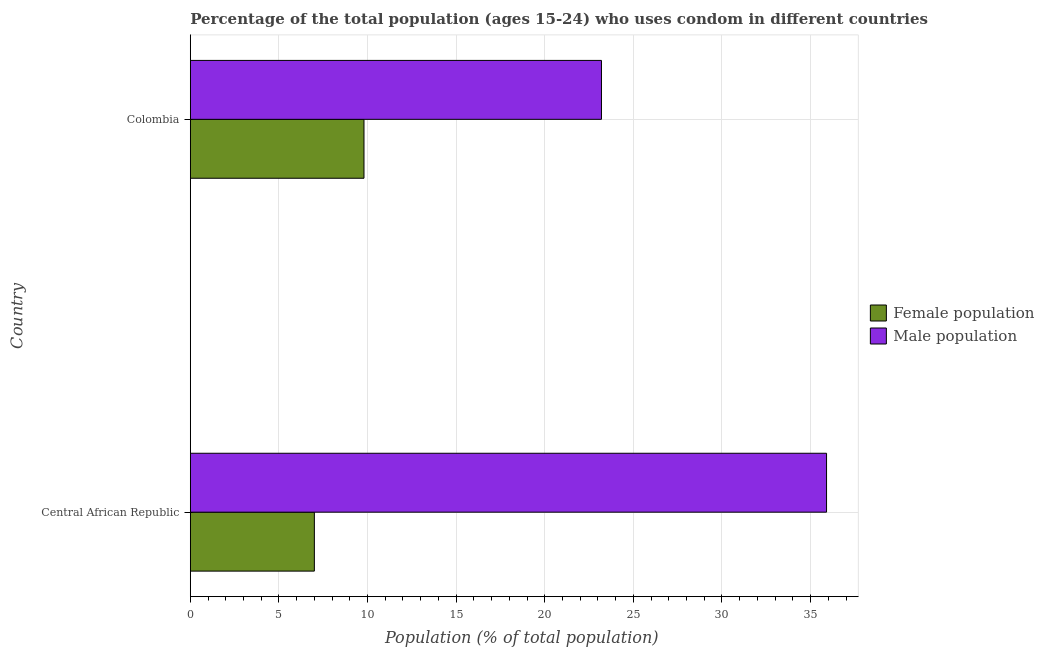How many groups of bars are there?
Offer a terse response. 2. Are the number of bars on each tick of the Y-axis equal?
Offer a very short reply. Yes. How many bars are there on the 1st tick from the top?
Provide a short and direct response. 2. How many bars are there on the 2nd tick from the bottom?
Make the answer very short. 2. What is the label of the 2nd group of bars from the top?
Keep it short and to the point. Central African Republic. In how many cases, is the number of bars for a given country not equal to the number of legend labels?
Your response must be concise. 0. What is the female population in Central African Republic?
Keep it short and to the point. 7. Across all countries, what is the maximum male population?
Your response must be concise. 35.9. Across all countries, what is the minimum male population?
Provide a short and direct response. 23.2. In which country was the female population minimum?
Offer a terse response. Central African Republic. What is the total male population in the graph?
Your response must be concise. 59.1. What is the difference between the female population in Central African Republic and that in Colombia?
Make the answer very short. -2.8. What is the difference between the male population in Central African Republic and the female population in Colombia?
Keep it short and to the point. 26.1. What is the difference between the male population and female population in Central African Republic?
Provide a succinct answer. 28.9. What is the ratio of the female population in Central African Republic to that in Colombia?
Your answer should be compact. 0.71. Is the difference between the male population in Central African Republic and Colombia greater than the difference between the female population in Central African Republic and Colombia?
Your answer should be compact. Yes. What does the 2nd bar from the top in Central African Republic represents?
Make the answer very short. Female population. What does the 1st bar from the bottom in Colombia represents?
Your answer should be compact. Female population. How many bars are there?
Your answer should be compact. 4. How many countries are there in the graph?
Ensure brevity in your answer.  2. What is the difference between two consecutive major ticks on the X-axis?
Your response must be concise. 5. Are the values on the major ticks of X-axis written in scientific E-notation?
Ensure brevity in your answer.  No. Does the graph contain any zero values?
Keep it short and to the point. No. What is the title of the graph?
Make the answer very short. Percentage of the total population (ages 15-24) who uses condom in different countries. Does "Under-five" appear as one of the legend labels in the graph?
Offer a terse response. No. What is the label or title of the X-axis?
Give a very brief answer. Population (% of total population) . What is the label or title of the Y-axis?
Provide a succinct answer. Country. What is the Population (% of total population)  of Male population in Central African Republic?
Provide a short and direct response. 35.9. What is the Population (% of total population)  of Female population in Colombia?
Offer a very short reply. 9.8. What is the Population (% of total population)  of Male population in Colombia?
Make the answer very short. 23.2. Across all countries, what is the maximum Population (% of total population)  of Male population?
Keep it short and to the point. 35.9. Across all countries, what is the minimum Population (% of total population)  of Male population?
Offer a terse response. 23.2. What is the total Population (% of total population)  of Male population in the graph?
Provide a succinct answer. 59.1. What is the difference between the Population (% of total population)  in Male population in Central African Republic and that in Colombia?
Your answer should be very brief. 12.7. What is the difference between the Population (% of total population)  of Female population in Central African Republic and the Population (% of total population)  of Male population in Colombia?
Ensure brevity in your answer.  -16.2. What is the average Population (% of total population)  of Male population per country?
Provide a succinct answer. 29.55. What is the difference between the Population (% of total population)  in Female population and Population (% of total population)  in Male population in Central African Republic?
Provide a short and direct response. -28.9. What is the difference between the Population (% of total population)  in Female population and Population (% of total population)  in Male population in Colombia?
Ensure brevity in your answer.  -13.4. What is the ratio of the Population (% of total population)  in Male population in Central African Republic to that in Colombia?
Your answer should be compact. 1.55. What is the difference between the highest and the second highest Population (% of total population)  in Male population?
Offer a very short reply. 12.7. What is the difference between the highest and the lowest Population (% of total population)  in Female population?
Your answer should be very brief. 2.8. What is the difference between the highest and the lowest Population (% of total population)  of Male population?
Provide a succinct answer. 12.7. 